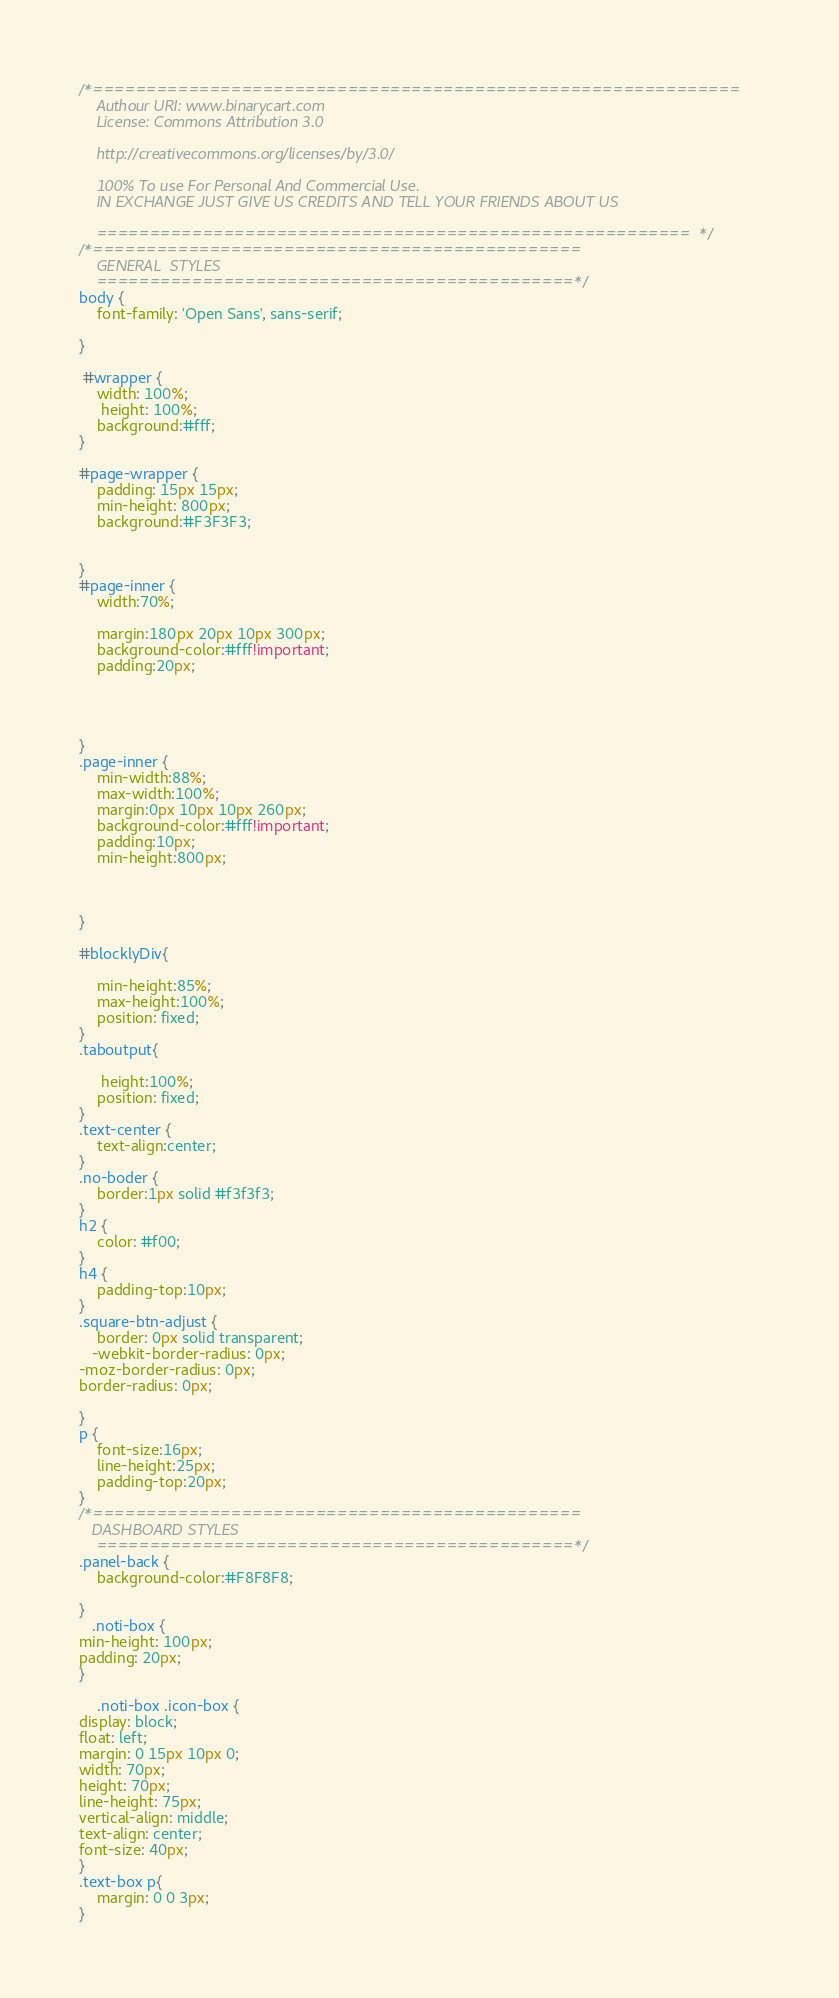<code> <loc_0><loc_0><loc_500><loc_500><_CSS_>
/*=============================================================
    Authour URI: www.binarycart.com
    License: Commons Attribution 3.0

    http://creativecommons.org/licenses/by/3.0/

    100% To use For Personal And Commercial Use.
    IN EXCHANGE JUST GIVE US CREDITS AND TELL YOUR FRIENDS ABOUT US
   
    ========================================================  */
/*==============================================
    GENERAL  STYLES    
    =============================================*/
body {
    font-family: 'Open Sans', sans-serif;
    
}

 #wrapper {
    width: 100%;
     height: 100%;
    background:#fff;
}

#page-wrapper {
    padding: 15px 15px;
    min-height: 800px;
    background:#F3F3F3;
    
   
}
#page-inner {
    width:70%;
  
    margin:180px 20px 10px 300px;
    background-color:#fff!important;
    padding:20px;
     
    
    
    
}
.page-inner {
    min-width:88%;
    max-width:100%;
    margin:0px 10px 10px 260px;
    background-color:#fff!important;
    padding:10px;
    min-height:800px;
    
   
    
}

#blocklyDiv{
    
    min-height:85%;
    max-height:100%;
    position: fixed;
}
.taboutput{
    
     height:100%;
    position: fixed;
}
.text-center {
    text-align:center;
}
.no-boder {
    border:1px solid #f3f3f3;
}
h2 {
    color: #f00;
}
h4 {
    padding-top:10px;
}
.square-btn-adjust {
    border: 0px solid transparent; 
   -webkit-border-radius: 0px;
-moz-border-radius: 0px;
border-radius: 0px;

}
p {
    font-size:16px;
    line-height:25px;
    padding-top:20px;
}
/*==============================================
   DASHBOARD STYLES    
    =============================================*/
.panel-back {
    background-color:#F8F8F8;

}
   .noti-box {
min-height: 100px;
padding: 20px;
}

    .noti-box .icon-box {
display: block;
float: left;
margin: 0 15px 10px 0;
width: 70px;
height: 70px;
line-height: 75px;
vertical-align: middle;
text-align: center;
font-size: 40px;
}
.text-box p{
    margin: 0 0 3px;
}</code> 